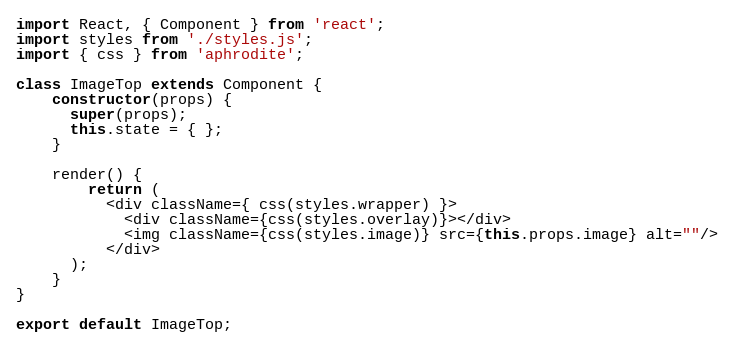<code> <loc_0><loc_0><loc_500><loc_500><_JavaScript_>import React, { Component } from 'react';
import styles from './styles.js';
import { css } from 'aphrodite';

class ImageTop extends Component {
    constructor(props) {
      super(props);
      this.state = { };
    }

    render() {
        return (
          <div className={ css(styles.wrapper) }>
            <div className={css(styles.overlay)}></div>
            <img className={css(styles.image)} src={this.props.image} alt=""/>
          </div>
      );
    }
}

export default ImageTop;
</code> 